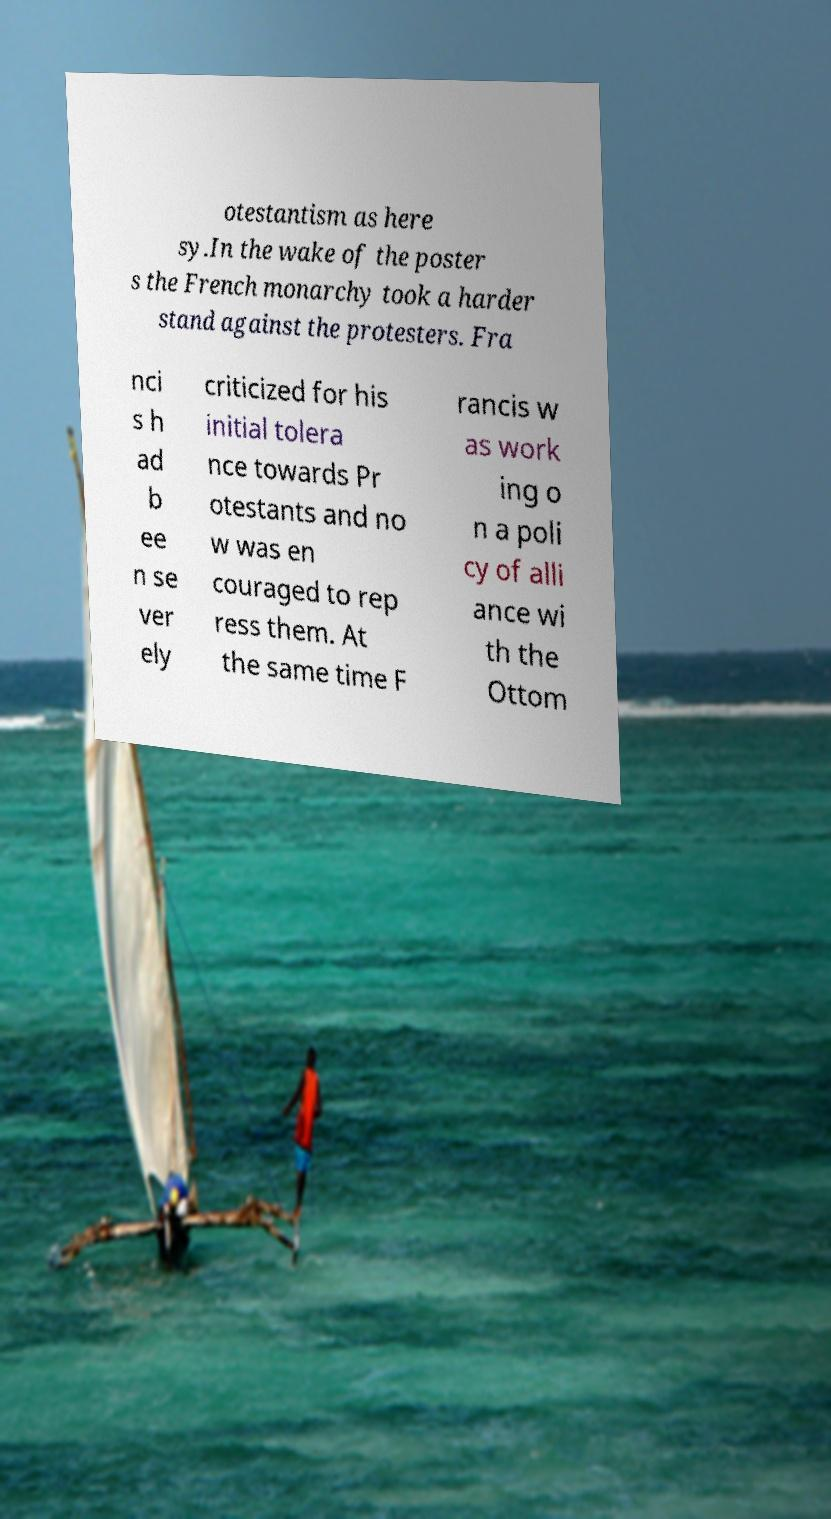For documentation purposes, I need the text within this image transcribed. Could you provide that? otestantism as here sy.In the wake of the poster s the French monarchy took a harder stand against the protesters. Fra nci s h ad b ee n se ver ely criticized for his initial tolera nce towards Pr otestants and no w was en couraged to rep ress them. At the same time F rancis w as work ing o n a poli cy of alli ance wi th the Ottom 